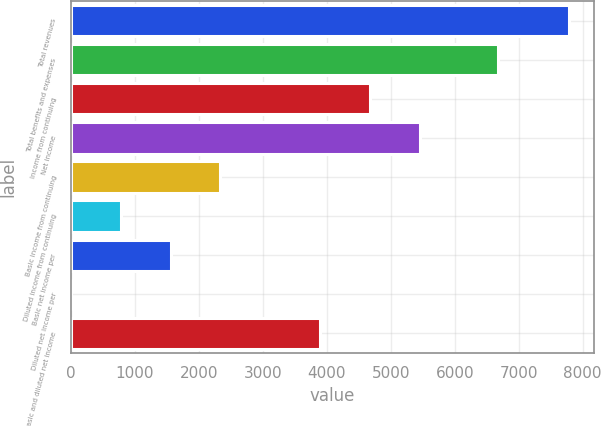Convert chart to OTSL. <chart><loc_0><loc_0><loc_500><loc_500><bar_chart><fcel>Total revenues<fcel>Total benefits and expenses<fcel>Income from continuing<fcel>Net income<fcel>Basic income from continuing<fcel>Diluted income from continuing<fcel>Basic net income per<fcel>Diluted net income per<fcel>Basic and diluted net income<nl><fcel>7787<fcel>6670<fcel>4673.23<fcel>5451.67<fcel>2337.91<fcel>781.03<fcel>1559.47<fcel>2.59<fcel>3894.79<nl></chart> 